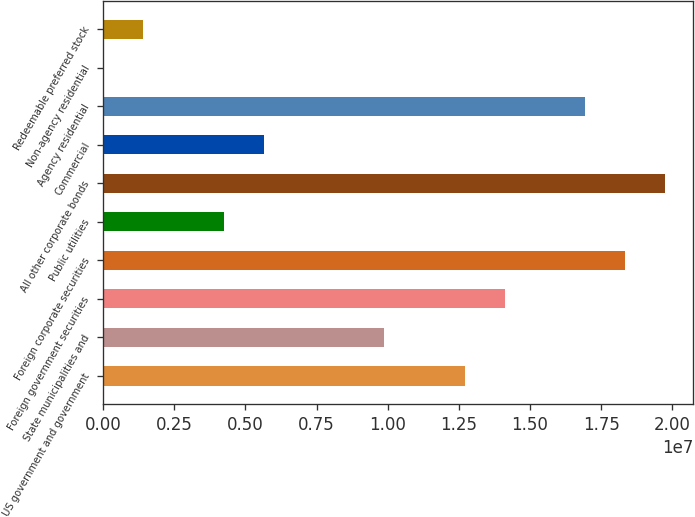Convert chart to OTSL. <chart><loc_0><loc_0><loc_500><loc_500><bar_chart><fcel>US government and government<fcel>State municipalities and<fcel>Foreign government securities<fcel>Foreign corporate securities<fcel>Public utilities<fcel>All other corporate bonds<fcel>Commercial<fcel>Agency residential<fcel>Non-agency residential<fcel>Redeemable preferred stock<nl><fcel>1.26967e+07<fcel>9.87538e+06<fcel>1.41074e+07<fcel>1.83394e+07<fcel>4.23267e+06<fcel>1.97501e+07<fcel>5.64335e+06<fcel>1.69288e+07<fcel>641<fcel>1.41132e+06<nl></chart> 